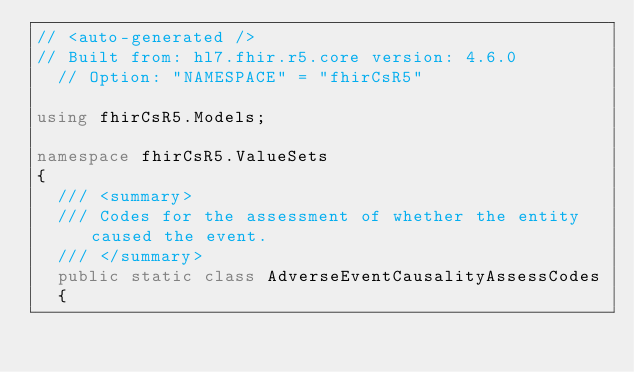Convert code to text. <code><loc_0><loc_0><loc_500><loc_500><_C#_>// <auto-generated />
// Built from: hl7.fhir.r5.core version: 4.6.0
  // Option: "NAMESPACE" = "fhirCsR5"

using fhirCsR5.Models;

namespace fhirCsR5.ValueSets
{
  /// <summary>
  /// Codes for the assessment of whether the entity caused the event.
  /// </summary>
  public static class AdverseEventCausalityAssessCodes
  {</code> 